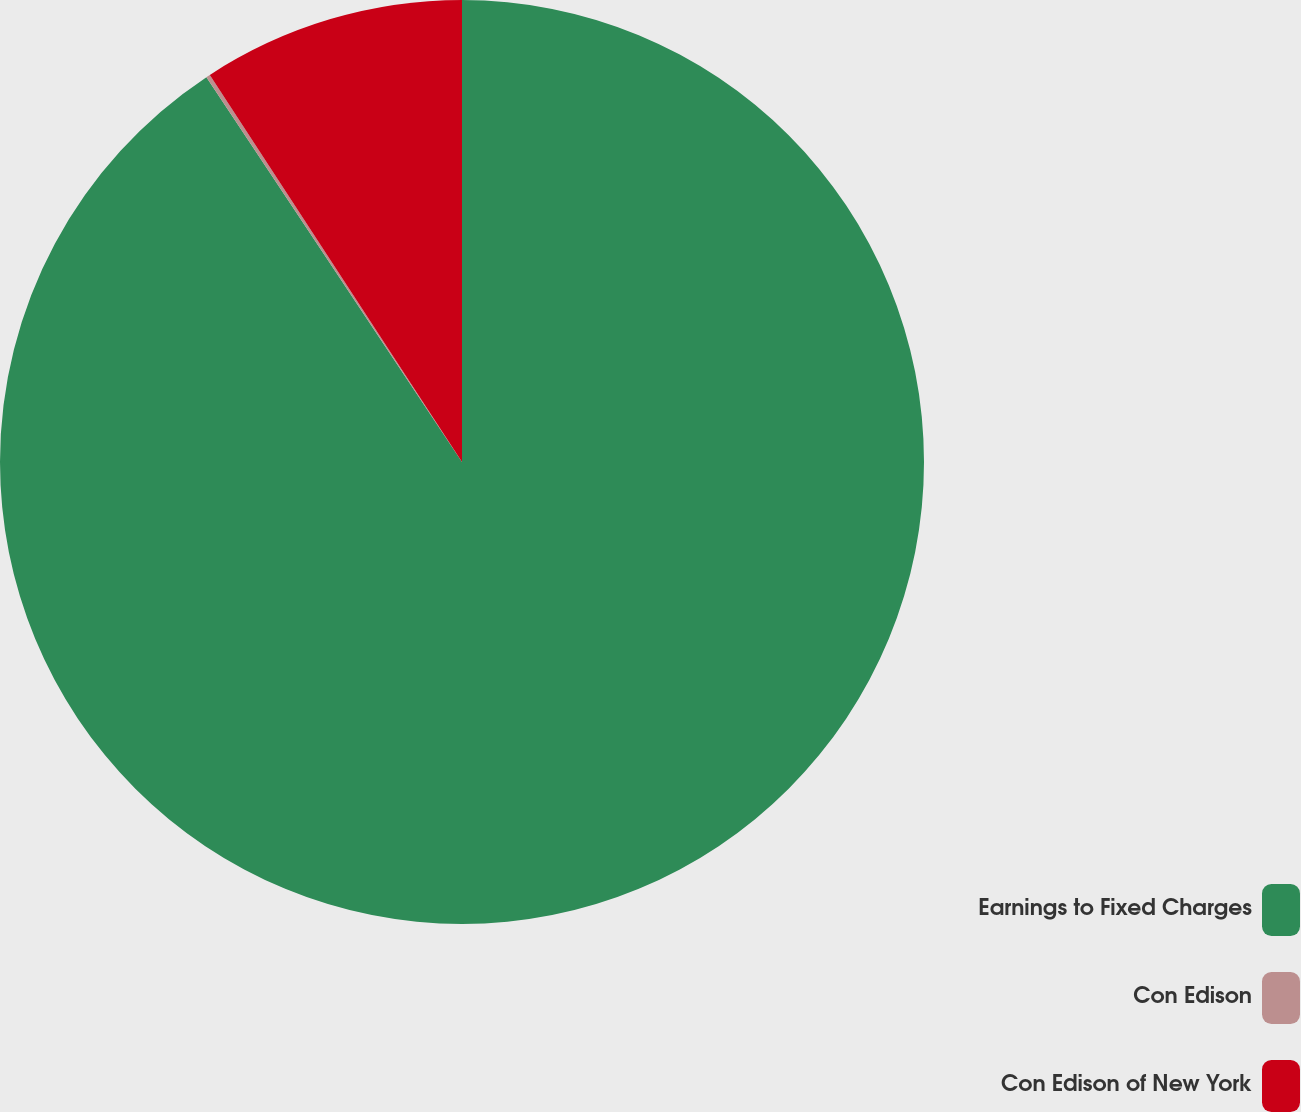<chart> <loc_0><loc_0><loc_500><loc_500><pie_chart><fcel>Earnings to Fixed Charges<fcel>Con Edison<fcel>Con Edison of New York<nl><fcel>90.67%<fcel>0.14%<fcel>9.19%<nl></chart> 